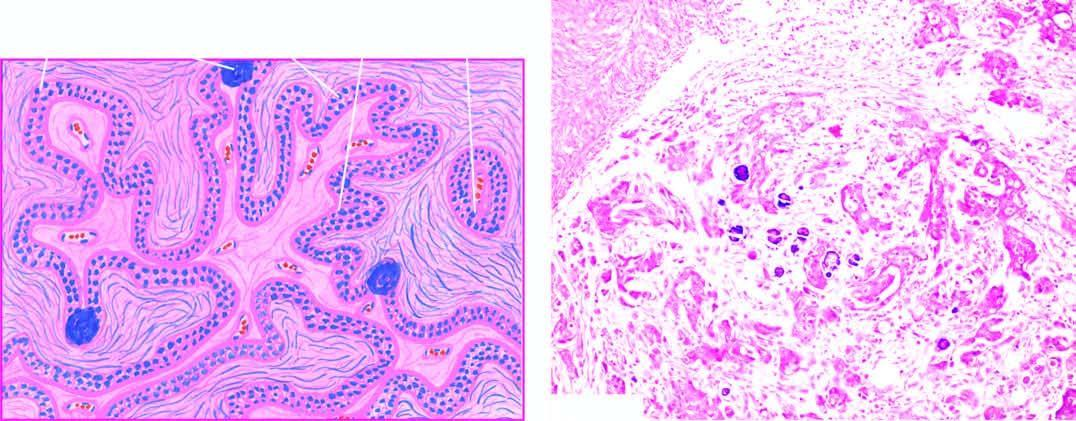does taghorn renal stone with chronic pyelonephritisthe kidney show invasion by clusters of anaplastic tumour cells?
Answer the question using a single word or phrase. No 